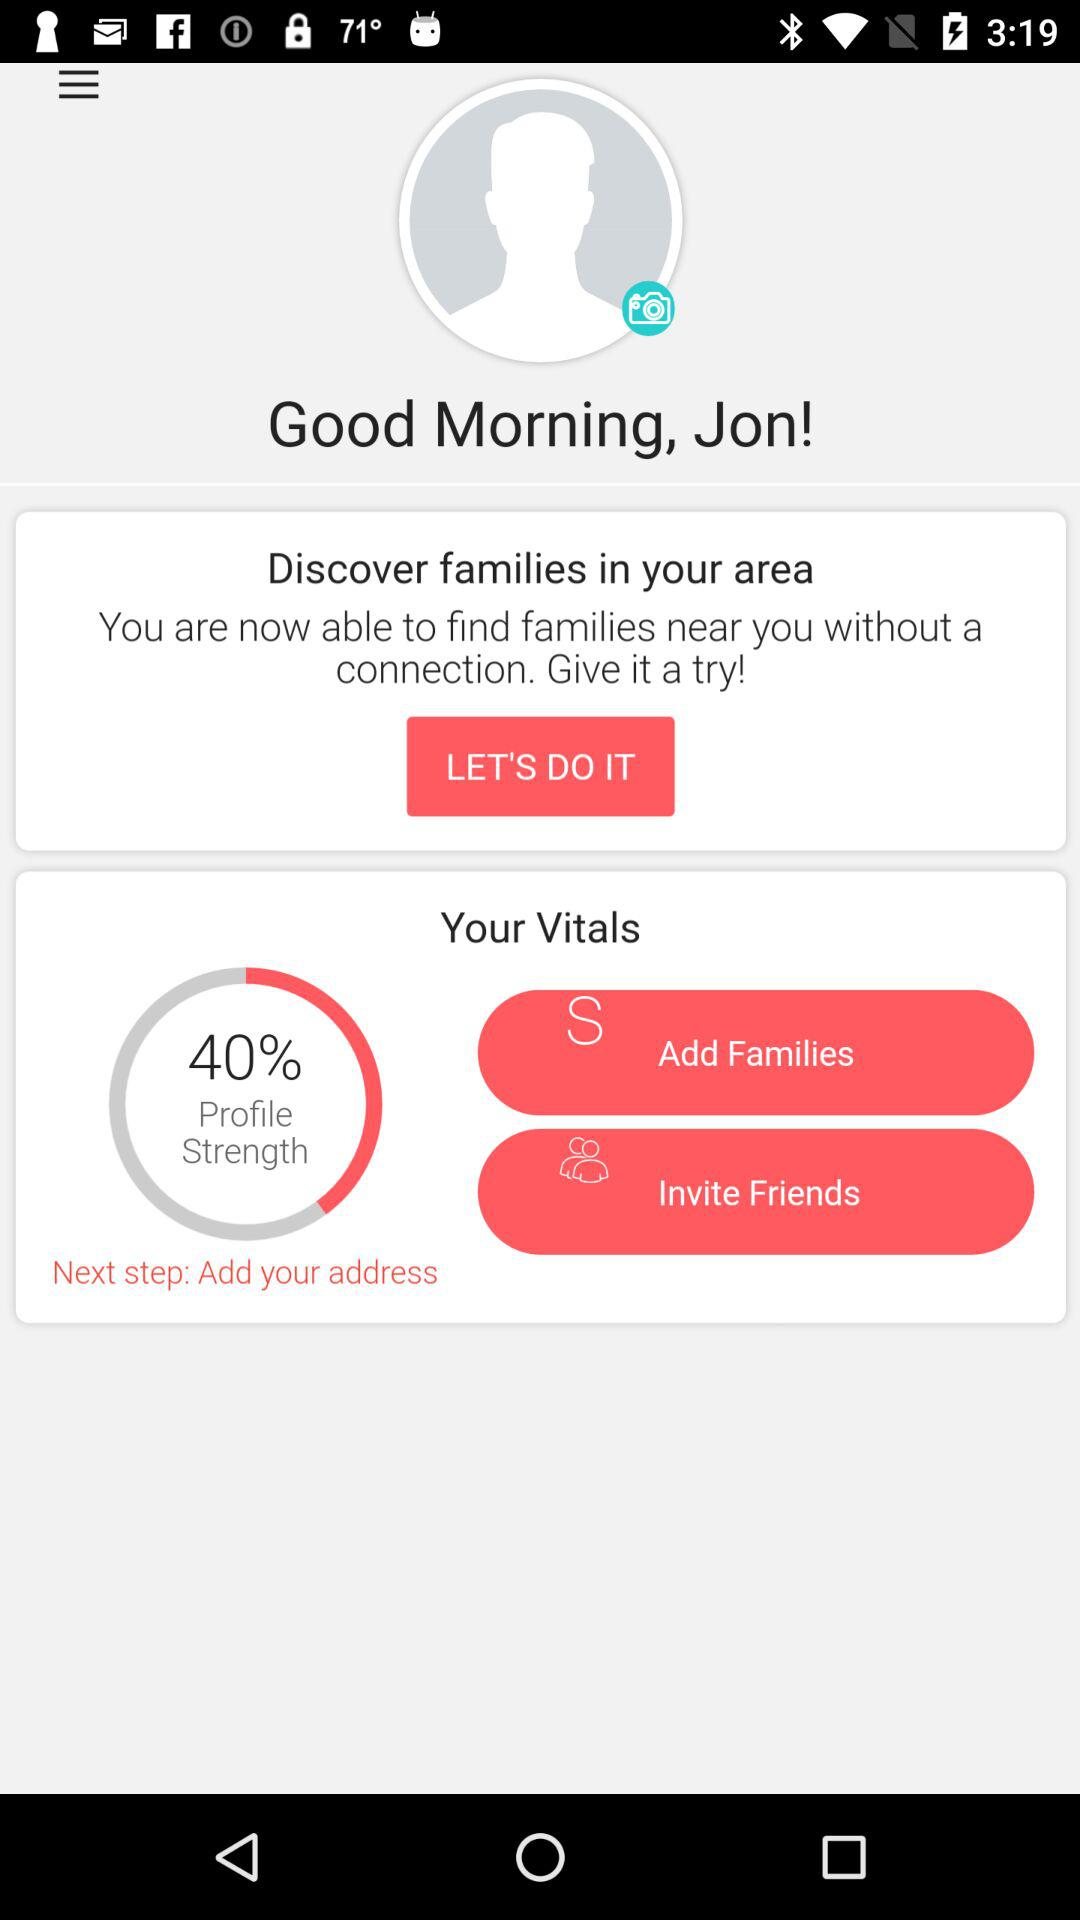What is the percentage of my profile strength?
Answer the question using a single word or phrase. 40% 